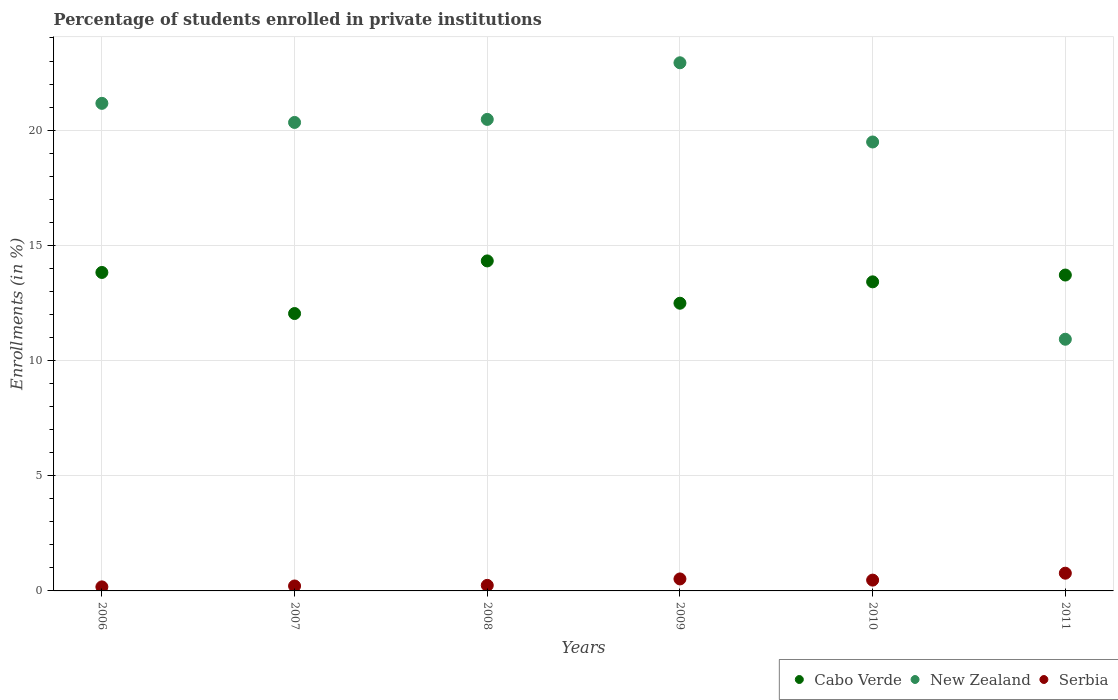How many different coloured dotlines are there?
Your response must be concise. 3. What is the percentage of trained teachers in Cabo Verde in 2011?
Your response must be concise. 13.71. Across all years, what is the maximum percentage of trained teachers in New Zealand?
Make the answer very short. 22.92. Across all years, what is the minimum percentage of trained teachers in New Zealand?
Ensure brevity in your answer.  10.92. In which year was the percentage of trained teachers in Cabo Verde maximum?
Offer a terse response. 2008. What is the total percentage of trained teachers in New Zealand in the graph?
Provide a short and direct response. 115.29. What is the difference between the percentage of trained teachers in Serbia in 2009 and that in 2011?
Your answer should be compact. -0.25. What is the difference between the percentage of trained teachers in Cabo Verde in 2008 and the percentage of trained teachers in New Zealand in 2007?
Offer a very short reply. -6.01. What is the average percentage of trained teachers in New Zealand per year?
Make the answer very short. 19.22. In the year 2009, what is the difference between the percentage of trained teachers in Serbia and percentage of trained teachers in New Zealand?
Your response must be concise. -22.4. In how many years, is the percentage of trained teachers in New Zealand greater than 17 %?
Offer a terse response. 5. What is the ratio of the percentage of trained teachers in New Zealand in 2009 to that in 2011?
Your response must be concise. 2.1. Is the difference between the percentage of trained teachers in Serbia in 2006 and 2009 greater than the difference between the percentage of trained teachers in New Zealand in 2006 and 2009?
Your answer should be very brief. Yes. What is the difference between the highest and the second highest percentage of trained teachers in Serbia?
Your response must be concise. 0.25. What is the difference between the highest and the lowest percentage of trained teachers in Serbia?
Offer a terse response. 0.59. Is the sum of the percentage of trained teachers in Cabo Verde in 2007 and 2011 greater than the maximum percentage of trained teachers in Serbia across all years?
Provide a short and direct response. Yes. Is it the case that in every year, the sum of the percentage of trained teachers in Cabo Verde and percentage of trained teachers in New Zealand  is greater than the percentage of trained teachers in Serbia?
Provide a short and direct response. Yes. How many dotlines are there?
Your answer should be very brief. 3. What is the difference between two consecutive major ticks on the Y-axis?
Your response must be concise. 5. Are the values on the major ticks of Y-axis written in scientific E-notation?
Your answer should be compact. No. Where does the legend appear in the graph?
Make the answer very short. Bottom right. How many legend labels are there?
Your response must be concise. 3. What is the title of the graph?
Make the answer very short. Percentage of students enrolled in private institutions. What is the label or title of the X-axis?
Offer a very short reply. Years. What is the label or title of the Y-axis?
Your answer should be very brief. Enrollments (in %). What is the Enrollments (in %) in Cabo Verde in 2006?
Ensure brevity in your answer.  13.82. What is the Enrollments (in %) of New Zealand in 2006?
Keep it short and to the point. 21.16. What is the Enrollments (in %) in Serbia in 2006?
Offer a very short reply. 0.18. What is the Enrollments (in %) of Cabo Verde in 2007?
Your answer should be very brief. 12.04. What is the Enrollments (in %) of New Zealand in 2007?
Your response must be concise. 20.33. What is the Enrollments (in %) of Serbia in 2007?
Give a very brief answer. 0.21. What is the Enrollments (in %) in Cabo Verde in 2008?
Ensure brevity in your answer.  14.32. What is the Enrollments (in %) in New Zealand in 2008?
Provide a succinct answer. 20.47. What is the Enrollments (in %) of Serbia in 2008?
Your response must be concise. 0.24. What is the Enrollments (in %) in Cabo Verde in 2009?
Offer a terse response. 12.49. What is the Enrollments (in %) in New Zealand in 2009?
Provide a succinct answer. 22.92. What is the Enrollments (in %) in Serbia in 2009?
Provide a succinct answer. 0.52. What is the Enrollments (in %) of Cabo Verde in 2010?
Your answer should be very brief. 13.42. What is the Enrollments (in %) in New Zealand in 2010?
Keep it short and to the point. 19.49. What is the Enrollments (in %) of Serbia in 2010?
Your answer should be compact. 0.47. What is the Enrollments (in %) of Cabo Verde in 2011?
Your answer should be very brief. 13.71. What is the Enrollments (in %) in New Zealand in 2011?
Provide a succinct answer. 10.92. What is the Enrollments (in %) of Serbia in 2011?
Give a very brief answer. 0.77. Across all years, what is the maximum Enrollments (in %) in Cabo Verde?
Give a very brief answer. 14.32. Across all years, what is the maximum Enrollments (in %) of New Zealand?
Offer a very short reply. 22.92. Across all years, what is the maximum Enrollments (in %) of Serbia?
Provide a succinct answer. 0.77. Across all years, what is the minimum Enrollments (in %) in Cabo Verde?
Provide a short and direct response. 12.04. Across all years, what is the minimum Enrollments (in %) in New Zealand?
Offer a terse response. 10.92. Across all years, what is the minimum Enrollments (in %) of Serbia?
Ensure brevity in your answer.  0.18. What is the total Enrollments (in %) of Cabo Verde in the graph?
Your answer should be compact. 79.8. What is the total Enrollments (in %) in New Zealand in the graph?
Make the answer very short. 115.29. What is the total Enrollments (in %) in Serbia in the graph?
Ensure brevity in your answer.  2.39. What is the difference between the Enrollments (in %) in Cabo Verde in 2006 and that in 2007?
Keep it short and to the point. 1.78. What is the difference between the Enrollments (in %) of New Zealand in 2006 and that in 2007?
Provide a short and direct response. 0.83. What is the difference between the Enrollments (in %) in Serbia in 2006 and that in 2007?
Keep it short and to the point. -0.04. What is the difference between the Enrollments (in %) of Cabo Verde in 2006 and that in 2008?
Offer a very short reply. -0.5. What is the difference between the Enrollments (in %) of New Zealand in 2006 and that in 2008?
Make the answer very short. 0.7. What is the difference between the Enrollments (in %) of Serbia in 2006 and that in 2008?
Provide a short and direct response. -0.07. What is the difference between the Enrollments (in %) in Cabo Verde in 2006 and that in 2009?
Provide a short and direct response. 1.34. What is the difference between the Enrollments (in %) of New Zealand in 2006 and that in 2009?
Give a very brief answer. -1.76. What is the difference between the Enrollments (in %) of Serbia in 2006 and that in 2009?
Provide a succinct answer. -0.34. What is the difference between the Enrollments (in %) of Cabo Verde in 2006 and that in 2010?
Keep it short and to the point. 0.41. What is the difference between the Enrollments (in %) of New Zealand in 2006 and that in 2010?
Offer a terse response. 1.68. What is the difference between the Enrollments (in %) in Serbia in 2006 and that in 2010?
Your response must be concise. -0.29. What is the difference between the Enrollments (in %) of Cabo Verde in 2006 and that in 2011?
Make the answer very short. 0.11. What is the difference between the Enrollments (in %) in New Zealand in 2006 and that in 2011?
Provide a short and direct response. 10.24. What is the difference between the Enrollments (in %) in Serbia in 2006 and that in 2011?
Your answer should be very brief. -0.59. What is the difference between the Enrollments (in %) of Cabo Verde in 2007 and that in 2008?
Offer a terse response. -2.28. What is the difference between the Enrollments (in %) in New Zealand in 2007 and that in 2008?
Keep it short and to the point. -0.13. What is the difference between the Enrollments (in %) of Serbia in 2007 and that in 2008?
Offer a very short reply. -0.03. What is the difference between the Enrollments (in %) in Cabo Verde in 2007 and that in 2009?
Your response must be concise. -0.45. What is the difference between the Enrollments (in %) of New Zealand in 2007 and that in 2009?
Give a very brief answer. -2.59. What is the difference between the Enrollments (in %) in Serbia in 2007 and that in 2009?
Your response must be concise. -0.31. What is the difference between the Enrollments (in %) in Cabo Verde in 2007 and that in 2010?
Provide a short and direct response. -1.38. What is the difference between the Enrollments (in %) in New Zealand in 2007 and that in 2010?
Your answer should be very brief. 0.85. What is the difference between the Enrollments (in %) of Serbia in 2007 and that in 2010?
Your answer should be compact. -0.25. What is the difference between the Enrollments (in %) of Cabo Verde in 2007 and that in 2011?
Your response must be concise. -1.67. What is the difference between the Enrollments (in %) of New Zealand in 2007 and that in 2011?
Keep it short and to the point. 9.41. What is the difference between the Enrollments (in %) in Serbia in 2007 and that in 2011?
Make the answer very short. -0.55. What is the difference between the Enrollments (in %) in Cabo Verde in 2008 and that in 2009?
Ensure brevity in your answer.  1.84. What is the difference between the Enrollments (in %) in New Zealand in 2008 and that in 2009?
Provide a short and direct response. -2.46. What is the difference between the Enrollments (in %) of Serbia in 2008 and that in 2009?
Your response must be concise. -0.28. What is the difference between the Enrollments (in %) of Cabo Verde in 2008 and that in 2010?
Keep it short and to the point. 0.91. What is the difference between the Enrollments (in %) in New Zealand in 2008 and that in 2010?
Provide a succinct answer. 0.98. What is the difference between the Enrollments (in %) in Serbia in 2008 and that in 2010?
Provide a succinct answer. -0.23. What is the difference between the Enrollments (in %) in Cabo Verde in 2008 and that in 2011?
Offer a very short reply. 0.61. What is the difference between the Enrollments (in %) in New Zealand in 2008 and that in 2011?
Give a very brief answer. 9.54. What is the difference between the Enrollments (in %) of Serbia in 2008 and that in 2011?
Ensure brevity in your answer.  -0.53. What is the difference between the Enrollments (in %) of Cabo Verde in 2009 and that in 2010?
Give a very brief answer. -0.93. What is the difference between the Enrollments (in %) of New Zealand in 2009 and that in 2010?
Give a very brief answer. 3.44. What is the difference between the Enrollments (in %) of Serbia in 2009 and that in 2010?
Offer a terse response. 0.05. What is the difference between the Enrollments (in %) in Cabo Verde in 2009 and that in 2011?
Keep it short and to the point. -1.22. What is the difference between the Enrollments (in %) in New Zealand in 2009 and that in 2011?
Offer a very short reply. 12. What is the difference between the Enrollments (in %) in Serbia in 2009 and that in 2011?
Give a very brief answer. -0.25. What is the difference between the Enrollments (in %) in Cabo Verde in 2010 and that in 2011?
Give a very brief answer. -0.3. What is the difference between the Enrollments (in %) of New Zealand in 2010 and that in 2011?
Give a very brief answer. 8.56. What is the difference between the Enrollments (in %) of Serbia in 2010 and that in 2011?
Provide a succinct answer. -0.3. What is the difference between the Enrollments (in %) in Cabo Verde in 2006 and the Enrollments (in %) in New Zealand in 2007?
Your answer should be very brief. -6.51. What is the difference between the Enrollments (in %) in Cabo Verde in 2006 and the Enrollments (in %) in Serbia in 2007?
Make the answer very short. 13.61. What is the difference between the Enrollments (in %) in New Zealand in 2006 and the Enrollments (in %) in Serbia in 2007?
Offer a terse response. 20.95. What is the difference between the Enrollments (in %) of Cabo Verde in 2006 and the Enrollments (in %) of New Zealand in 2008?
Your answer should be very brief. -6.64. What is the difference between the Enrollments (in %) in Cabo Verde in 2006 and the Enrollments (in %) in Serbia in 2008?
Your answer should be compact. 13.58. What is the difference between the Enrollments (in %) of New Zealand in 2006 and the Enrollments (in %) of Serbia in 2008?
Offer a terse response. 20.92. What is the difference between the Enrollments (in %) of Cabo Verde in 2006 and the Enrollments (in %) of New Zealand in 2009?
Offer a terse response. -9.1. What is the difference between the Enrollments (in %) in Cabo Verde in 2006 and the Enrollments (in %) in Serbia in 2009?
Your answer should be very brief. 13.3. What is the difference between the Enrollments (in %) of New Zealand in 2006 and the Enrollments (in %) of Serbia in 2009?
Your response must be concise. 20.64. What is the difference between the Enrollments (in %) in Cabo Verde in 2006 and the Enrollments (in %) in New Zealand in 2010?
Offer a terse response. -5.66. What is the difference between the Enrollments (in %) in Cabo Verde in 2006 and the Enrollments (in %) in Serbia in 2010?
Make the answer very short. 13.35. What is the difference between the Enrollments (in %) of New Zealand in 2006 and the Enrollments (in %) of Serbia in 2010?
Make the answer very short. 20.69. What is the difference between the Enrollments (in %) of Cabo Verde in 2006 and the Enrollments (in %) of New Zealand in 2011?
Offer a terse response. 2.9. What is the difference between the Enrollments (in %) of Cabo Verde in 2006 and the Enrollments (in %) of Serbia in 2011?
Make the answer very short. 13.05. What is the difference between the Enrollments (in %) in New Zealand in 2006 and the Enrollments (in %) in Serbia in 2011?
Make the answer very short. 20.39. What is the difference between the Enrollments (in %) in Cabo Verde in 2007 and the Enrollments (in %) in New Zealand in 2008?
Make the answer very short. -8.43. What is the difference between the Enrollments (in %) of Cabo Verde in 2007 and the Enrollments (in %) of Serbia in 2008?
Your answer should be very brief. 11.8. What is the difference between the Enrollments (in %) of New Zealand in 2007 and the Enrollments (in %) of Serbia in 2008?
Give a very brief answer. 20.09. What is the difference between the Enrollments (in %) of Cabo Verde in 2007 and the Enrollments (in %) of New Zealand in 2009?
Offer a very short reply. -10.88. What is the difference between the Enrollments (in %) in Cabo Verde in 2007 and the Enrollments (in %) in Serbia in 2009?
Provide a succinct answer. 11.52. What is the difference between the Enrollments (in %) in New Zealand in 2007 and the Enrollments (in %) in Serbia in 2009?
Provide a succinct answer. 19.81. What is the difference between the Enrollments (in %) in Cabo Verde in 2007 and the Enrollments (in %) in New Zealand in 2010?
Keep it short and to the point. -7.45. What is the difference between the Enrollments (in %) in Cabo Verde in 2007 and the Enrollments (in %) in Serbia in 2010?
Your answer should be very brief. 11.57. What is the difference between the Enrollments (in %) of New Zealand in 2007 and the Enrollments (in %) of Serbia in 2010?
Offer a very short reply. 19.86. What is the difference between the Enrollments (in %) of Cabo Verde in 2007 and the Enrollments (in %) of New Zealand in 2011?
Provide a succinct answer. 1.12. What is the difference between the Enrollments (in %) in Cabo Verde in 2007 and the Enrollments (in %) in Serbia in 2011?
Ensure brevity in your answer.  11.27. What is the difference between the Enrollments (in %) of New Zealand in 2007 and the Enrollments (in %) of Serbia in 2011?
Make the answer very short. 19.56. What is the difference between the Enrollments (in %) in Cabo Verde in 2008 and the Enrollments (in %) in New Zealand in 2009?
Your response must be concise. -8.6. What is the difference between the Enrollments (in %) of Cabo Verde in 2008 and the Enrollments (in %) of Serbia in 2009?
Provide a short and direct response. 13.8. What is the difference between the Enrollments (in %) of New Zealand in 2008 and the Enrollments (in %) of Serbia in 2009?
Ensure brevity in your answer.  19.95. What is the difference between the Enrollments (in %) of Cabo Verde in 2008 and the Enrollments (in %) of New Zealand in 2010?
Your answer should be very brief. -5.16. What is the difference between the Enrollments (in %) of Cabo Verde in 2008 and the Enrollments (in %) of Serbia in 2010?
Make the answer very short. 13.85. What is the difference between the Enrollments (in %) of New Zealand in 2008 and the Enrollments (in %) of Serbia in 2010?
Provide a succinct answer. 20. What is the difference between the Enrollments (in %) of Cabo Verde in 2008 and the Enrollments (in %) of New Zealand in 2011?
Ensure brevity in your answer.  3.4. What is the difference between the Enrollments (in %) in Cabo Verde in 2008 and the Enrollments (in %) in Serbia in 2011?
Your response must be concise. 13.55. What is the difference between the Enrollments (in %) in New Zealand in 2008 and the Enrollments (in %) in Serbia in 2011?
Your response must be concise. 19.7. What is the difference between the Enrollments (in %) in Cabo Verde in 2009 and the Enrollments (in %) in New Zealand in 2010?
Provide a succinct answer. -7. What is the difference between the Enrollments (in %) in Cabo Verde in 2009 and the Enrollments (in %) in Serbia in 2010?
Your response must be concise. 12.02. What is the difference between the Enrollments (in %) of New Zealand in 2009 and the Enrollments (in %) of Serbia in 2010?
Give a very brief answer. 22.45. What is the difference between the Enrollments (in %) of Cabo Verde in 2009 and the Enrollments (in %) of New Zealand in 2011?
Give a very brief answer. 1.56. What is the difference between the Enrollments (in %) in Cabo Verde in 2009 and the Enrollments (in %) in Serbia in 2011?
Your answer should be compact. 11.72. What is the difference between the Enrollments (in %) of New Zealand in 2009 and the Enrollments (in %) of Serbia in 2011?
Your answer should be very brief. 22.15. What is the difference between the Enrollments (in %) of Cabo Verde in 2010 and the Enrollments (in %) of New Zealand in 2011?
Your answer should be compact. 2.49. What is the difference between the Enrollments (in %) in Cabo Verde in 2010 and the Enrollments (in %) in Serbia in 2011?
Provide a short and direct response. 12.65. What is the difference between the Enrollments (in %) of New Zealand in 2010 and the Enrollments (in %) of Serbia in 2011?
Make the answer very short. 18.72. What is the average Enrollments (in %) of Cabo Verde per year?
Offer a very short reply. 13.3. What is the average Enrollments (in %) of New Zealand per year?
Provide a succinct answer. 19.22. What is the average Enrollments (in %) in Serbia per year?
Offer a terse response. 0.4. In the year 2006, what is the difference between the Enrollments (in %) of Cabo Verde and Enrollments (in %) of New Zealand?
Your response must be concise. -7.34. In the year 2006, what is the difference between the Enrollments (in %) of Cabo Verde and Enrollments (in %) of Serbia?
Give a very brief answer. 13.65. In the year 2006, what is the difference between the Enrollments (in %) in New Zealand and Enrollments (in %) in Serbia?
Keep it short and to the point. 20.99. In the year 2007, what is the difference between the Enrollments (in %) of Cabo Verde and Enrollments (in %) of New Zealand?
Keep it short and to the point. -8.29. In the year 2007, what is the difference between the Enrollments (in %) in Cabo Verde and Enrollments (in %) in Serbia?
Your answer should be compact. 11.83. In the year 2007, what is the difference between the Enrollments (in %) of New Zealand and Enrollments (in %) of Serbia?
Keep it short and to the point. 20.12. In the year 2008, what is the difference between the Enrollments (in %) of Cabo Verde and Enrollments (in %) of New Zealand?
Give a very brief answer. -6.14. In the year 2008, what is the difference between the Enrollments (in %) of Cabo Verde and Enrollments (in %) of Serbia?
Provide a short and direct response. 14.08. In the year 2008, what is the difference between the Enrollments (in %) of New Zealand and Enrollments (in %) of Serbia?
Offer a terse response. 20.22. In the year 2009, what is the difference between the Enrollments (in %) of Cabo Verde and Enrollments (in %) of New Zealand?
Provide a succinct answer. -10.44. In the year 2009, what is the difference between the Enrollments (in %) of Cabo Verde and Enrollments (in %) of Serbia?
Ensure brevity in your answer.  11.97. In the year 2009, what is the difference between the Enrollments (in %) in New Zealand and Enrollments (in %) in Serbia?
Your response must be concise. 22.4. In the year 2010, what is the difference between the Enrollments (in %) in Cabo Verde and Enrollments (in %) in New Zealand?
Your answer should be compact. -6.07. In the year 2010, what is the difference between the Enrollments (in %) in Cabo Verde and Enrollments (in %) in Serbia?
Give a very brief answer. 12.95. In the year 2010, what is the difference between the Enrollments (in %) of New Zealand and Enrollments (in %) of Serbia?
Your answer should be very brief. 19.02. In the year 2011, what is the difference between the Enrollments (in %) in Cabo Verde and Enrollments (in %) in New Zealand?
Ensure brevity in your answer.  2.79. In the year 2011, what is the difference between the Enrollments (in %) in Cabo Verde and Enrollments (in %) in Serbia?
Your answer should be very brief. 12.94. In the year 2011, what is the difference between the Enrollments (in %) in New Zealand and Enrollments (in %) in Serbia?
Make the answer very short. 10.15. What is the ratio of the Enrollments (in %) of Cabo Verde in 2006 to that in 2007?
Offer a very short reply. 1.15. What is the ratio of the Enrollments (in %) in New Zealand in 2006 to that in 2007?
Provide a short and direct response. 1.04. What is the ratio of the Enrollments (in %) of Serbia in 2006 to that in 2007?
Ensure brevity in your answer.  0.82. What is the ratio of the Enrollments (in %) in New Zealand in 2006 to that in 2008?
Your response must be concise. 1.03. What is the ratio of the Enrollments (in %) of Serbia in 2006 to that in 2008?
Provide a short and direct response. 0.73. What is the ratio of the Enrollments (in %) of Cabo Verde in 2006 to that in 2009?
Keep it short and to the point. 1.11. What is the ratio of the Enrollments (in %) of New Zealand in 2006 to that in 2009?
Provide a succinct answer. 0.92. What is the ratio of the Enrollments (in %) of Serbia in 2006 to that in 2009?
Provide a succinct answer. 0.34. What is the ratio of the Enrollments (in %) of Cabo Verde in 2006 to that in 2010?
Offer a very short reply. 1.03. What is the ratio of the Enrollments (in %) of New Zealand in 2006 to that in 2010?
Offer a very short reply. 1.09. What is the ratio of the Enrollments (in %) of Serbia in 2006 to that in 2010?
Your answer should be very brief. 0.37. What is the ratio of the Enrollments (in %) of Cabo Verde in 2006 to that in 2011?
Make the answer very short. 1.01. What is the ratio of the Enrollments (in %) in New Zealand in 2006 to that in 2011?
Ensure brevity in your answer.  1.94. What is the ratio of the Enrollments (in %) in Serbia in 2006 to that in 2011?
Keep it short and to the point. 0.23. What is the ratio of the Enrollments (in %) of Cabo Verde in 2007 to that in 2008?
Your answer should be compact. 0.84. What is the ratio of the Enrollments (in %) in New Zealand in 2007 to that in 2008?
Your answer should be very brief. 0.99. What is the ratio of the Enrollments (in %) in Serbia in 2007 to that in 2008?
Ensure brevity in your answer.  0.89. What is the ratio of the Enrollments (in %) of Cabo Verde in 2007 to that in 2009?
Your answer should be compact. 0.96. What is the ratio of the Enrollments (in %) in New Zealand in 2007 to that in 2009?
Ensure brevity in your answer.  0.89. What is the ratio of the Enrollments (in %) of Serbia in 2007 to that in 2009?
Provide a succinct answer. 0.41. What is the ratio of the Enrollments (in %) of Cabo Verde in 2007 to that in 2010?
Keep it short and to the point. 0.9. What is the ratio of the Enrollments (in %) of New Zealand in 2007 to that in 2010?
Your answer should be very brief. 1.04. What is the ratio of the Enrollments (in %) of Serbia in 2007 to that in 2010?
Offer a terse response. 0.46. What is the ratio of the Enrollments (in %) of Cabo Verde in 2007 to that in 2011?
Offer a terse response. 0.88. What is the ratio of the Enrollments (in %) in New Zealand in 2007 to that in 2011?
Your response must be concise. 1.86. What is the ratio of the Enrollments (in %) in Serbia in 2007 to that in 2011?
Your response must be concise. 0.28. What is the ratio of the Enrollments (in %) in Cabo Verde in 2008 to that in 2009?
Make the answer very short. 1.15. What is the ratio of the Enrollments (in %) in New Zealand in 2008 to that in 2009?
Offer a terse response. 0.89. What is the ratio of the Enrollments (in %) in Serbia in 2008 to that in 2009?
Make the answer very short. 0.46. What is the ratio of the Enrollments (in %) in Cabo Verde in 2008 to that in 2010?
Provide a succinct answer. 1.07. What is the ratio of the Enrollments (in %) of New Zealand in 2008 to that in 2010?
Your answer should be very brief. 1.05. What is the ratio of the Enrollments (in %) of Serbia in 2008 to that in 2010?
Offer a terse response. 0.51. What is the ratio of the Enrollments (in %) of Cabo Verde in 2008 to that in 2011?
Offer a very short reply. 1.04. What is the ratio of the Enrollments (in %) in New Zealand in 2008 to that in 2011?
Provide a short and direct response. 1.87. What is the ratio of the Enrollments (in %) in Serbia in 2008 to that in 2011?
Make the answer very short. 0.31. What is the ratio of the Enrollments (in %) in Cabo Verde in 2009 to that in 2010?
Make the answer very short. 0.93. What is the ratio of the Enrollments (in %) of New Zealand in 2009 to that in 2010?
Your answer should be very brief. 1.18. What is the ratio of the Enrollments (in %) of Serbia in 2009 to that in 2010?
Give a very brief answer. 1.11. What is the ratio of the Enrollments (in %) of Cabo Verde in 2009 to that in 2011?
Your answer should be very brief. 0.91. What is the ratio of the Enrollments (in %) in New Zealand in 2009 to that in 2011?
Offer a very short reply. 2.1. What is the ratio of the Enrollments (in %) of Serbia in 2009 to that in 2011?
Provide a short and direct response. 0.68. What is the ratio of the Enrollments (in %) in Cabo Verde in 2010 to that in 2011?
Your answer should be compact. 0.98. What is the ratio of the Enrollments (in %) in New Zealand in 2010 to that in 2011?
Your response must be concise. 1.78. What is the ratio of the Enrollments (in %) in Serbia in 2010 to that in 2011?
Provide a succinct answer. 0.61. What is the difference between the highest and the second highest Enrollments (in %) of Cabo Verde?
Keep it short and to the point. 0.5. What is the difference between the highest and the second highest Enrollments (in %) in New Zealand?
Provide a succinct answer. 1.76. What is the difference between the highest and the second highest Enrollments (in %) in Serbia?
Ensure brevity in your answer.  0.25. What is the difference between the highest and the lowest Enrollments (in %) of Cabo Verde?
Give a very brief answer. 2.28. What is the difference between the highest and the lowest Enrollments (in %) of New Zealand?
Your answer should be compact. 12. What is the difference between the highest and the lowest Enrollments (in %) of Serbia?
Offer a very short reply. 0.59. 